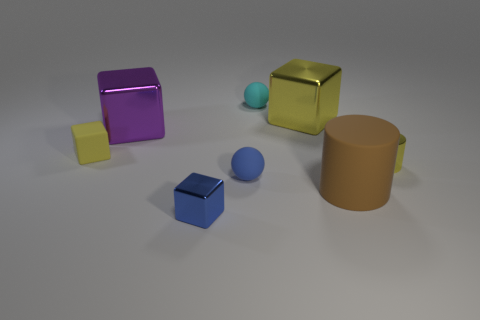Add 1 brown rubber cylinders. How many objects exist? 9 Subtract all balls. How many objects are left? 6 Subtract 0 brown spheres. How many objects are left? 8 Subtract all purple metallic things. Subtract all metal cylinders. How many objects are left? 6 Add 7 large brown cylinders. How many large brown cylinders are left? 8 Add 7 large yellow rubber blocks. How many large yellow rubber blocks exist? 7 